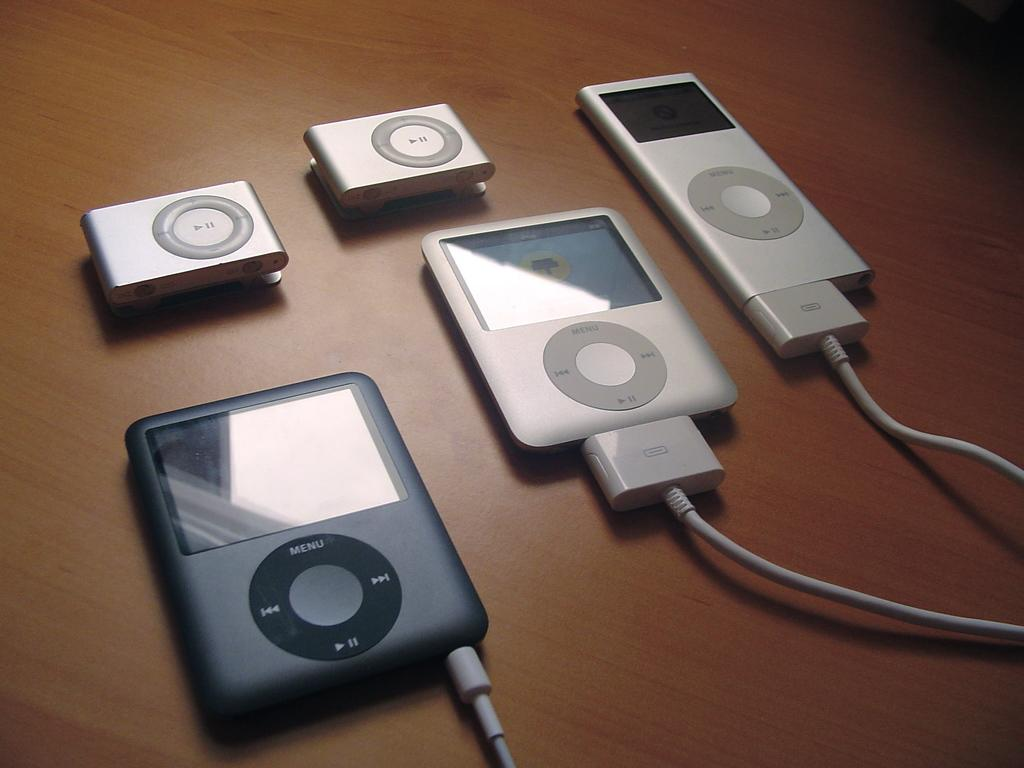What is located in the center of the image? There are electronic devices and wires in the center of the image. Can you describe the electronic devices in the image? Unfortunately, the image does not provide enough detail to describe the electronic devices. What is the table used for in the image? The table is likely used to hold or support the electronic devices and wires, but the specific purpose is not clear from the image. What type of paste is being applied to the chin in the image? There is no paste or chin present in the image; it only features electronic devices, wires, and a table. 